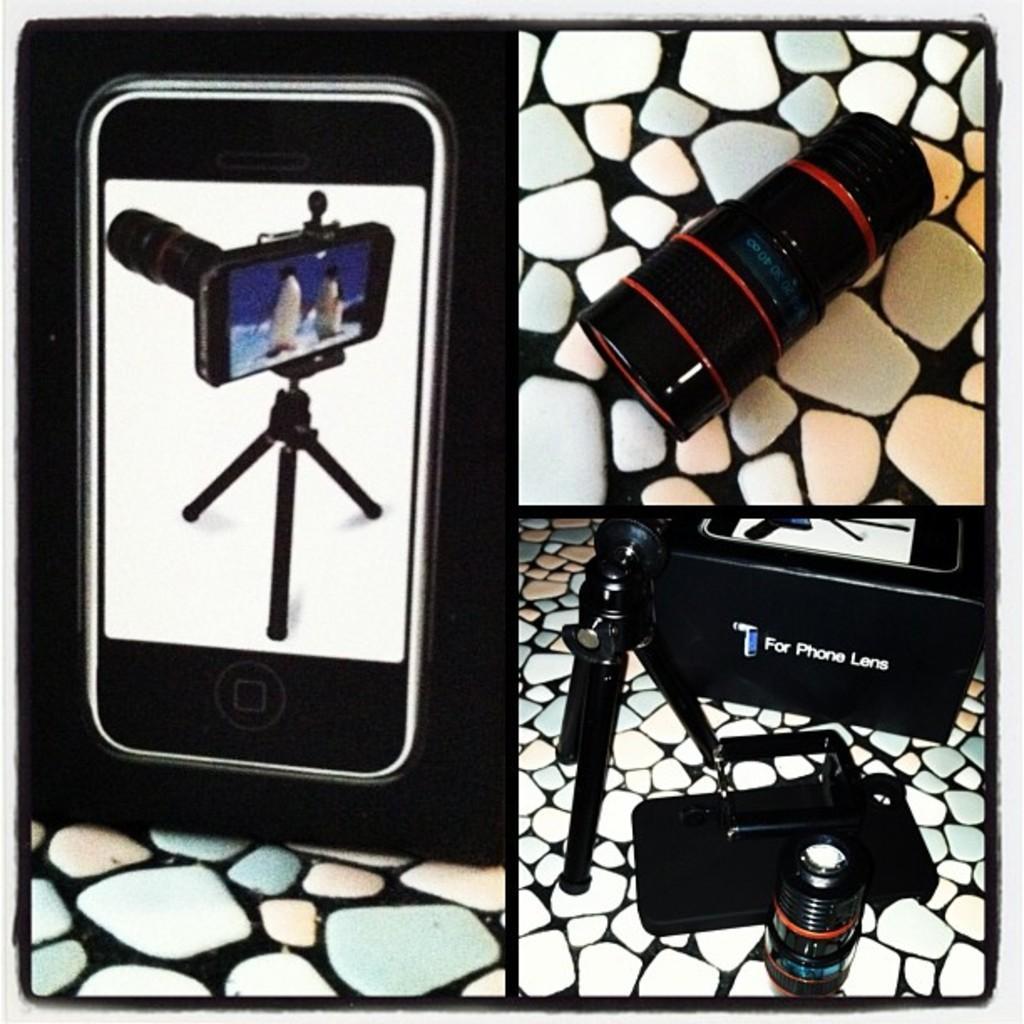How would you summarize this image in a sentence or two? This is a collage image. In this image I can see mobile box, lens, stand and bag. These are on the marble floor. 